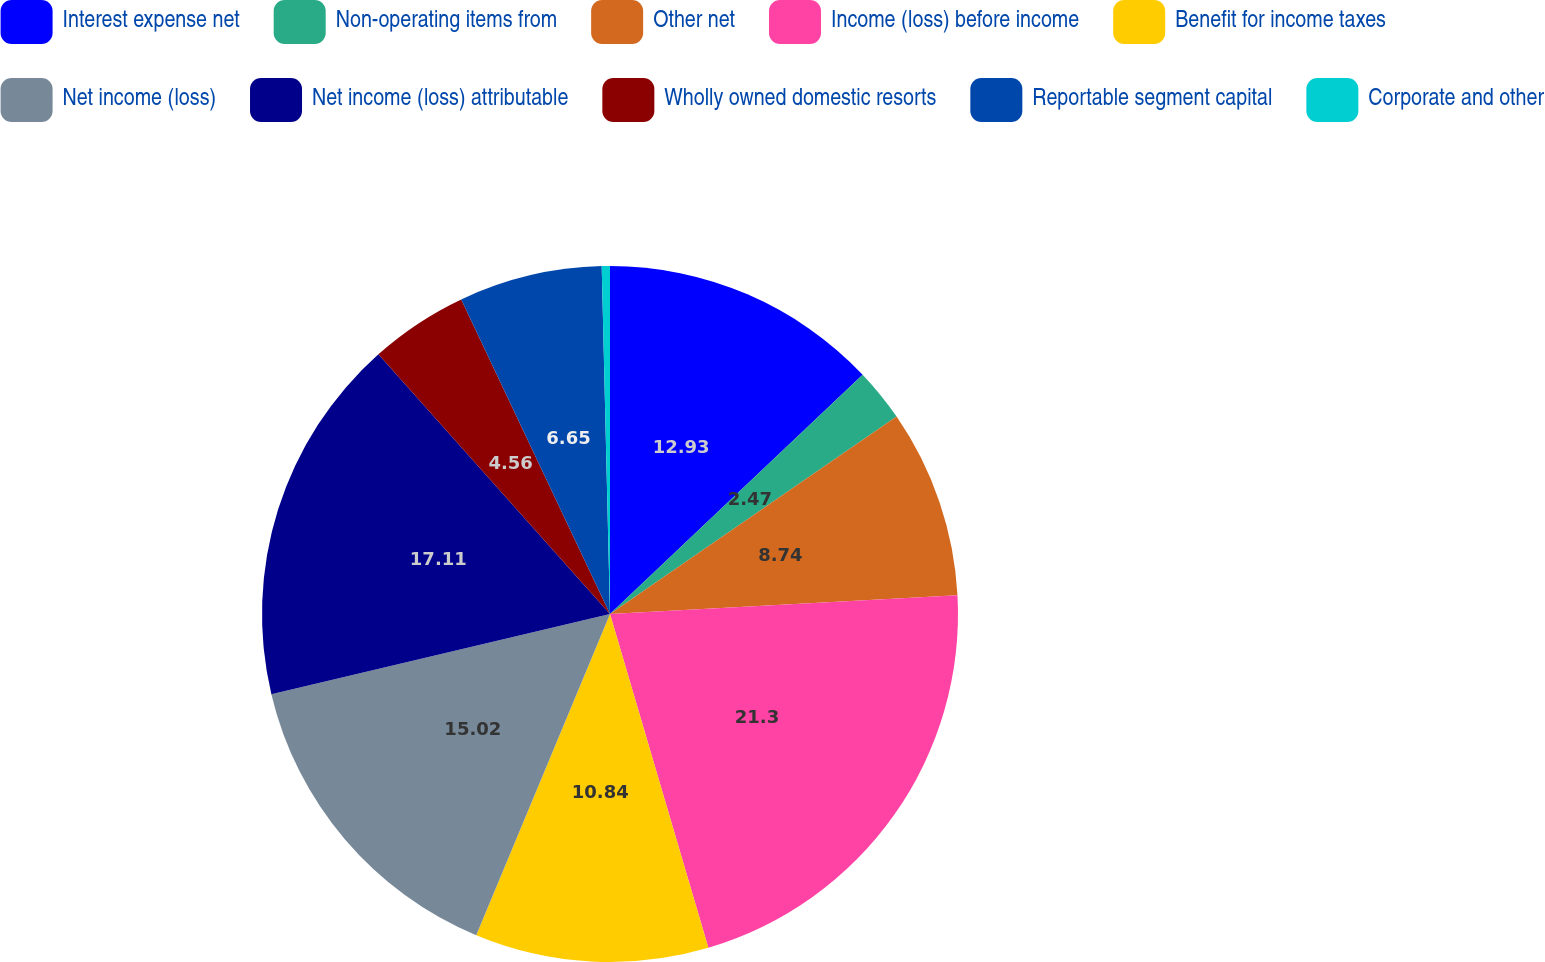Convert chart to OTSL. <chart><loc_0><loc_0><loc_500><loc_500><pie_chart><fcel>Interest expense net<fcel>Non-operating items from<fcel>Other net<fcel>Income (loss) before income<fcel>Benefit for income taxes<fcel>Net income (loss)<fcel>Net income (loss) attributable<fcel>Wholly owned domestic resorts<fcel>Reportable segment capital<fcel>Corporate and other<nl><fcel>12.93%<fcel>2.47%<fcel>8.74%<fcel>21.3%<fcel>10.84%<fcel>15.02%<fcel>17.11%<fcel>4.56%<fcel>6.65%<fcel>0.38%<nl></chart> 